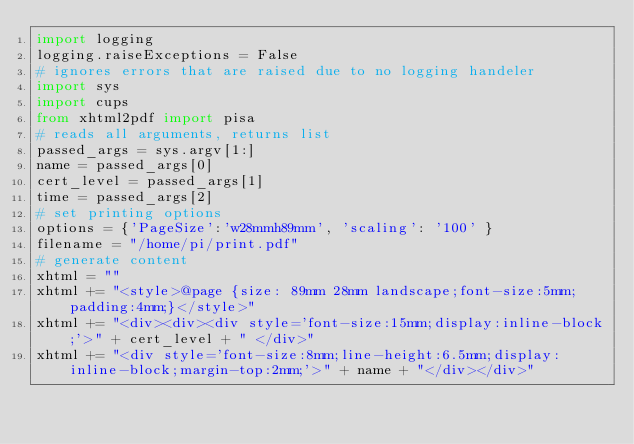<code> <loc_0><loc_0><loc_500><loc_500><_Python_>import logging
logging.raiseExceptions = False 
# ignores errors that are raised due to no logging handeler
import sys
import cups 
from xhtml2pdf import pisa 
# reads all arguments, returns list
passed_args = sys.argv[1:]
name = passed_args[0]
cert_level = passed_args[1]
time = passed_args[2]
# set printing options 
options = {'PageSize':'w28mmh89mm', 'scaling': '100' }
filename = "/home/pi/print.pdf" 
# generate content 
xhtml = "" 
xhtml += "<style>@page {size: 89mm 28mm landscape;font-size:5mm;padding:4mm;}</style>"
xhtml += "<div><div><div style='font-size:15mm;display:inline-block;'>" + cert_level + " </div>"
xhtml += "<div style='font-size:8mm;line-height:6.5mm;display:inline-block;margin-top:2mm;'>" + name + "</div></div>"</code> 